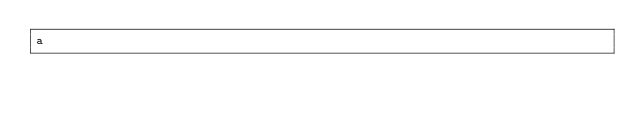<code> <loc_0><loc_0><loc_500><loc_500><_JavaScript_>a</code> 